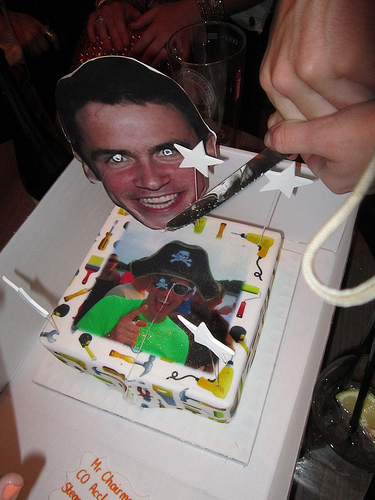Please provide the bounding box coordinate of the region this sentence describes: a beer glass from a restaurant. The most probable location for the beer glass, as depicted in the festive setting, would be within the coordinates [0.45, 0.04, 0.62, 0.29], where one might spot a clear glass with a tempting, frothy beverage. 